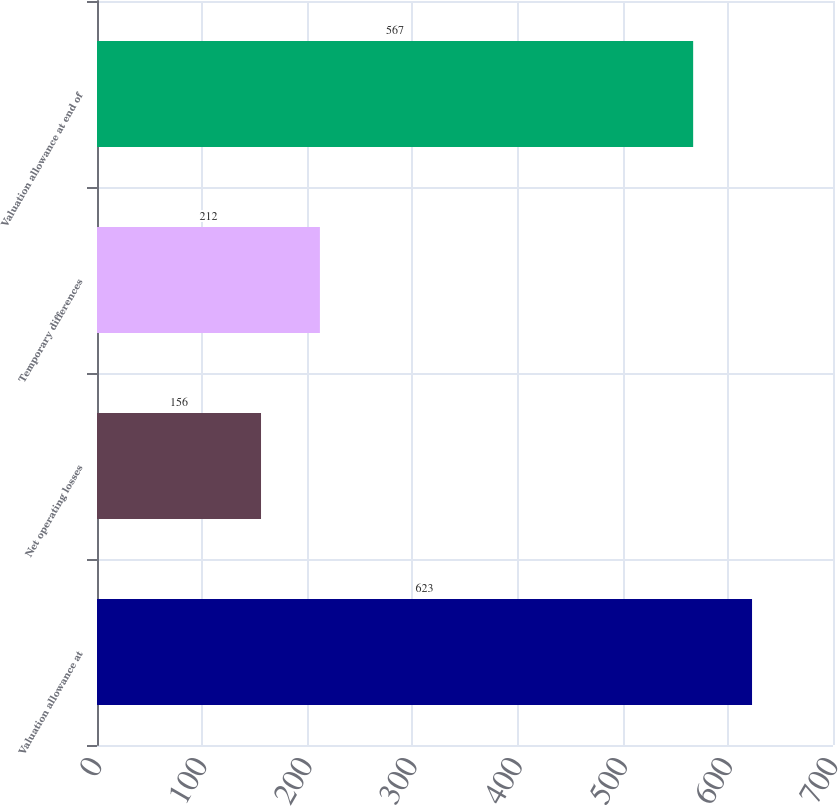Convert chart. <chart><loc_0><loc_0><loc_500><loc_500><bar_chart><fcel>Valuation allowance at<fcel>Net operating losses<fcel>Temporary differences<fcel>Valuation allowance at end of<nl><fcel>623<fcel>156<fcel>212<fcel>567<nl></chart> 